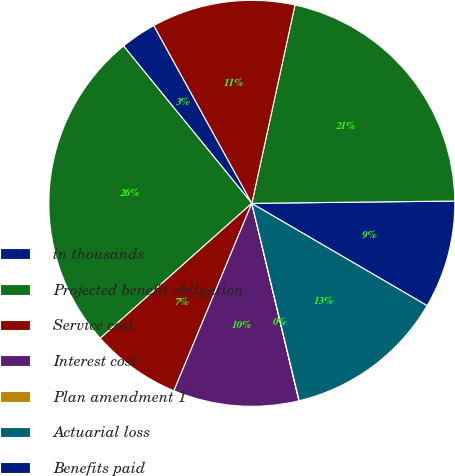Convert chart. <chart><loc_0><loc_0><loc_500><loc_500><pie_chart><fcel>in thousands<fcel>Projected benefit obligation<fcel>Service cost<fcel>Interest cost<fcel>Plan amendment 1<fcel>Actuarial loss<fcel>Benefits paid<fcel>Fair value of assets at<fcel>Actual return on plan assets<nl><fcel>2.87%<fcel>25.69%<fcel>7.15%<fcel>10.0%<fcel>0.02%<fcel>12.85%<fcel>8.58%<fcel>21.41%<fcel>11.43%<nl></chart> 